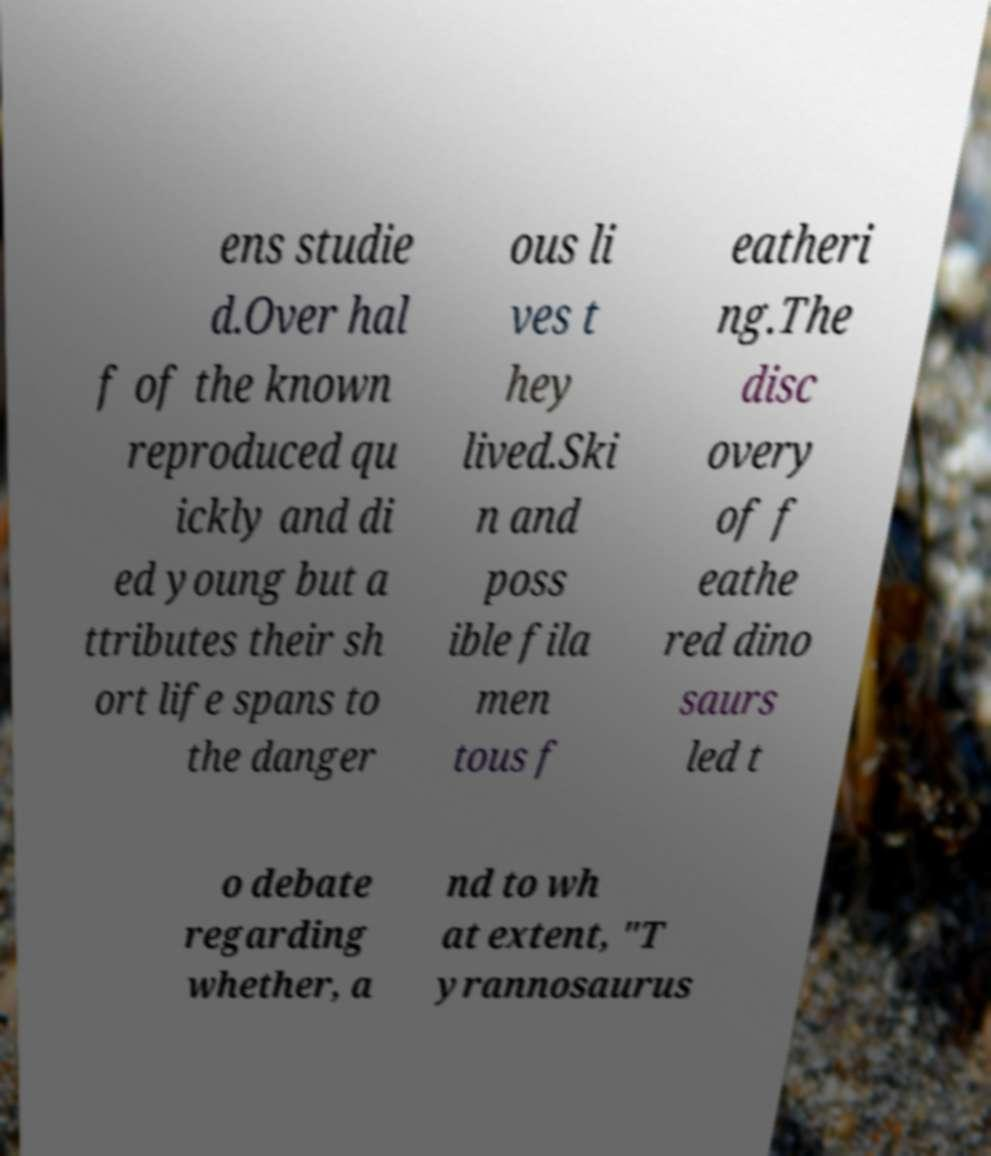Can you accurately transcribe the text from the provided image for me? ens studie d.Over hal f of the known reproduced qu ickly and di ed young but a ttributes their sh ort life spans to the danger ous li ves t hey lived.Ski n and poss ible fila men tous f eatheri ng.The disc overy of f eathe red dino saurs led t o debate regarding whether, a nd to wh at extent, "T yrannosaurus 